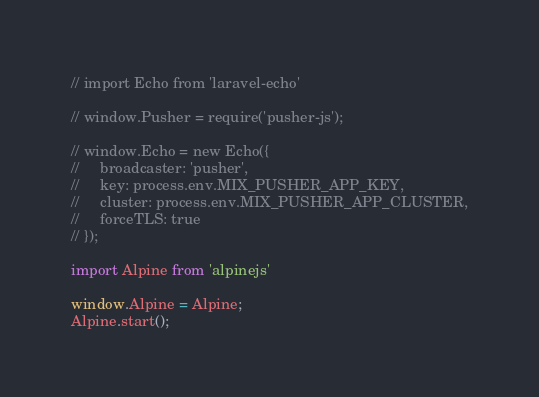<code> <loc_0><loc_0><loc_500><loc_500><_JavaScript_>// import Echo from 'laravel-echo'

// window.Pusher = require('pusher-js');

// window.Echo = new Echo({
//     broadcaster: 'pusher',
//     key: process.env.MIX_PUSHER_APP_KEY,
//     cluster: process.env.MIX_PUSHER_APP_CLUSTER,
//     forceTLS: true
// });

import Alpine from 'alpinejs'

window.Alpine = Alpine;
Alpine.start();

</code> 